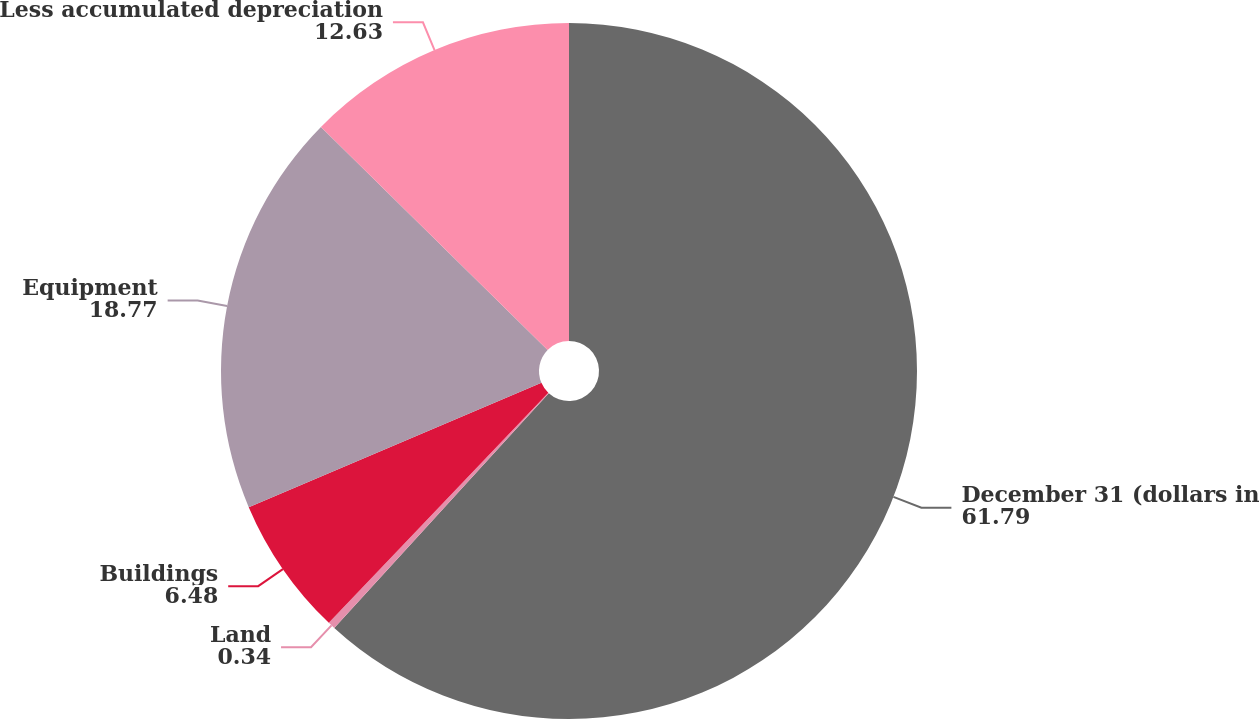Convert chart. <chart><loc_0><loc_0><loc_500><loc_500><pie_chart><fcel>December 31 (dollars in<fcel>Land<fcel>Buildings<fcel>Equipment<fcel>Less accumulated depreciation<nl><fcel>61.79%<fcel>0.34%<fcel>6.48%<fcel>18.77%<fcel>12.63%<nl></chart> 